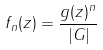<formula> <loc_0><loc_0><loc_500><loc_500>f _ { n } ( z ) = \frac { g ( z ) ^ { n } } { | G | }</formula> 